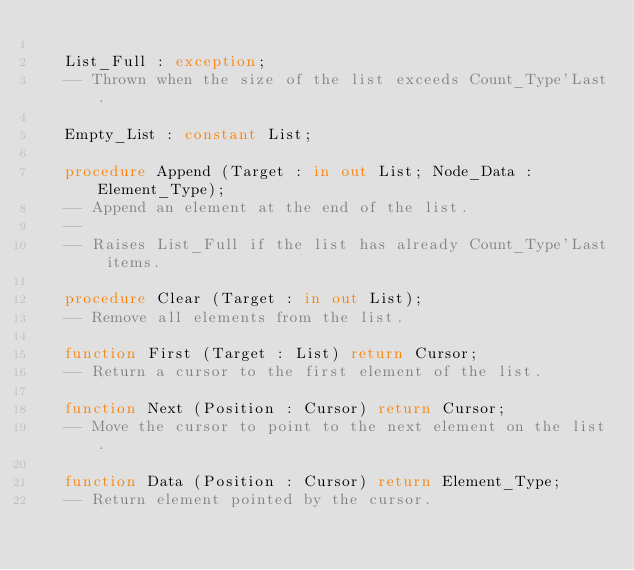<code> <loc_0><loc_0><loc_500><loc_500><_Ada_>
   List_Full : exception;
   -- Thrown when the size of the list exceeds Count_Type'Last.

   Empty_List : constant List;

   procedure Append (Target : in out List; Node_Data : Element_Type);
   -- Append an element at the end of the list.
   --
   -- Raises List_Full if the list has already Count_Type'Last items.

   procedure Clear (Target : in out List);
   -- Remove all elements from the list.

   function First (Target : List) return Cursor;
   -- Return a cursor to the first element of the list.

   function Next (Position : Cursor) return Cursor;
   -- Move the cursor to point to the next element on the list.

   function Data (Position : Cursor) return Element_Type;
   -- Return element pointed by the cursor.
</code> 